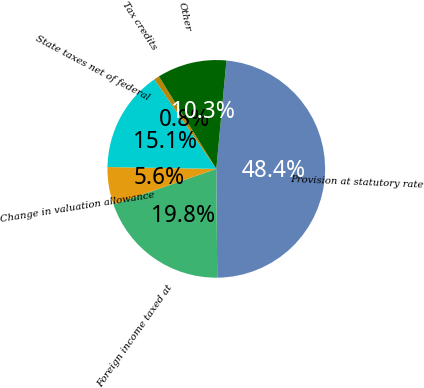Convert chart. <chart><loc_0><loc_0><loc_500><loc_500><pie_chart><fcel>Provision at statutory rate<fcel>Foreign income taxed at<fcel>Change in valuation allowance<fcel>State taxes net of federal<fcel>Tax credits<fcel>Other<nl><fcel>48.37%<fcel>19.84%<fcel>5.57%<fcel>15.08%<fcel>0.81%<fcel>10.33%<nl></chart> 